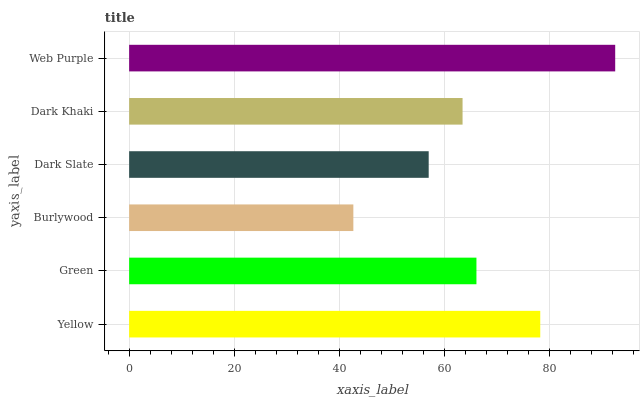Is Burlywood the minimum?
Answer yes or no. Yes. Is Web Purple the maximum?
Answer yes or no. Yes. Is Green the minimum?
Answer yes or no. No. Is Green the maximum?
Answer yes or no. No. Is Yellow greater than Green?
Answer yes or no. Yes. Is Green less than Yellow?
Answer yes or no. Yes. Is Green greater than Yellow?
Answer yes or no. No. Is Yellow less than Green?
Answer yes or no. No. Is Green the high median?
Answer yes or no. Yes. Is Dark Khaki the low median?
Answer yes or no. Yes. Is Burlywood the high median?
Answer yes or no. No. Is Green the low median?
Answer yes or no. No. 